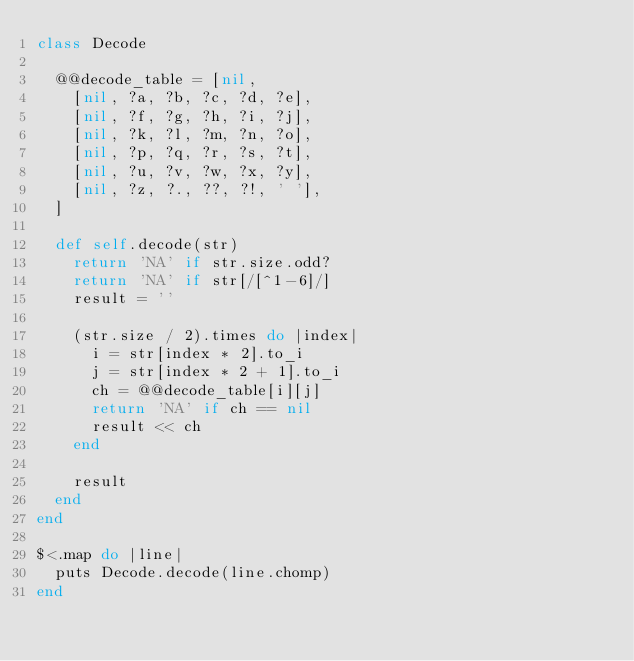Convert code to text. <code><loc_0><loc_0><loc_500><loc_500><_Ruby_>class Decode

  @@decode_table = [nil,
    [nil, ?a, ?b, ?c, ?d, ?e],
    [nil, ?f, ?g, ?h, ?i, ?j],
    [nil, ?k, ?l, ?m, ?n, ?o],
    [nil, ?p, ?q, ?r, ?s, ?t],
    [nil, ?u, ?v, ?w, ?x, ?y],
    [nil, ?z, ?., ??, ?!, ' '],
  ]

  def self.decode(str)
    return 'NA' if str.size.odd?
    return 'NA' if str[/[^1-6]/]
    result = ''

    (str.size / 2).times do |index|
      i = str[index * 2].to_i
      j = str[index * 2 + 1].to_i
      ch = @@decode_table[i][j]
      return 'NA' if ch == nil
      result << ch
    end

    result
  end
end

$<.map do |line|
  puts Decode.decode(line.chomp)
end</code> 